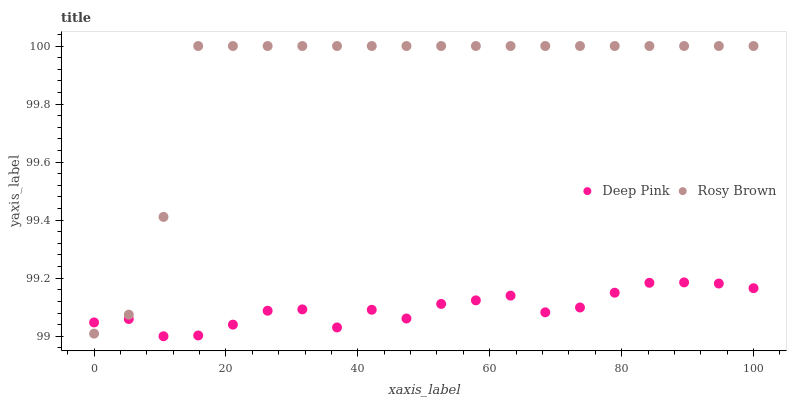Does Deep Pink have the minimum area under the curve?
Answer yes or no. Yes. Does Rosy Brown have the maximum area under the curve?
Answer yes or no. Yes. Does Deep Pink have the maximum area under the curve?
Answer yes or no. No. Is Deep Pink the smoothest?
Answer yes or no. Yes. Is Rosy Brown the roughest?
Answer yes or no. Yes. Is Deep Pink the roughest?
Answer yes or no. No. Does Deep Pink have the lowest value?
Answer yes or no. Yes. Does Rosy Brown have the highest value?
Answer yes or no. Yes. Does Deep Pink have the highest value?
Answer yes or no. No. Does Rosy Brown intersect Deep Pink?
Answer yes or no. Yes. Is Rosy Brown less than Deep Pink?
Answer yes or no. No. Is Rosy Brown greater than Deep Pink?
Answer yes or no. No. 